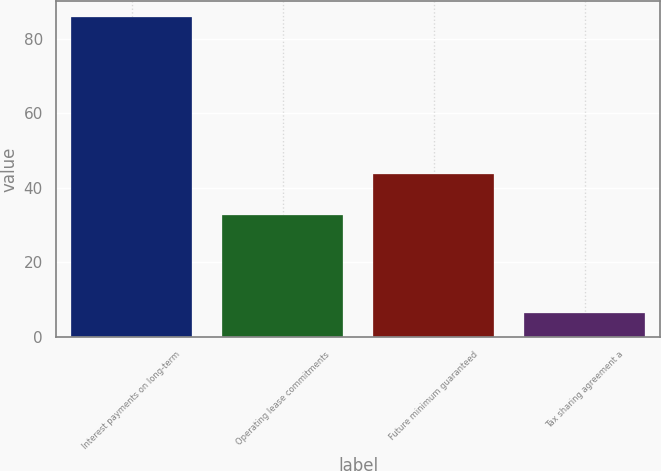<chart> <loc_0><loc_0><loc_500><loc_500><bar_chart><fcel>Interest payments on long-term<fcel>Operating lease commitments<fcel>Future minimum guaranteed<fcel>Tax sharing agreement a<nl><fcel>85.8<fcel>32.8<fcel>43.6<fcel>6.4<nl></chart> 